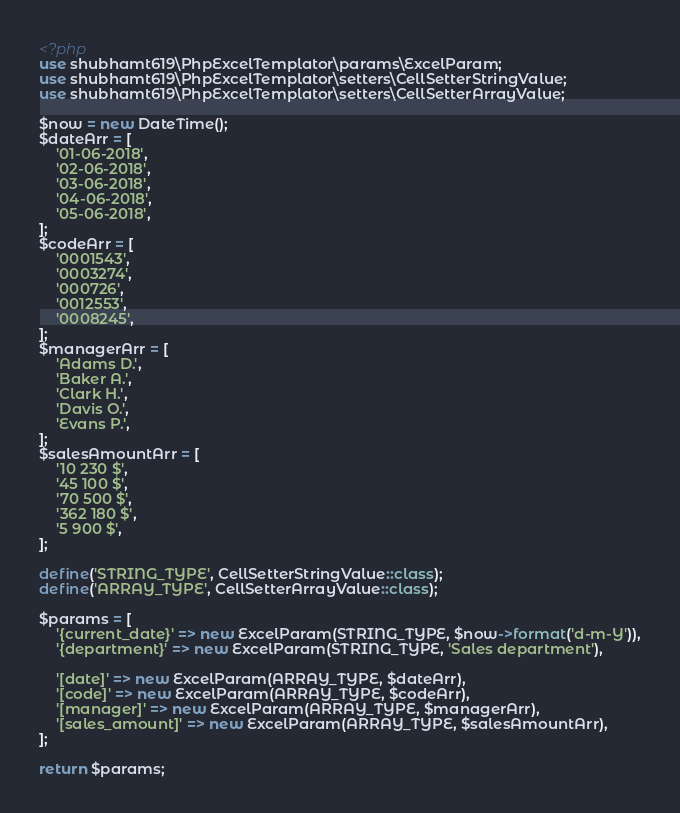<code> <loc_0><loc_0><loc_500><loc_500><_PHP_><?php
use shubhamt619\PhpExcelTemplator\params\ExcelParam;
use shubhamt619\PhpExcelTemplator\setters\CellSetterStringValue;
use shubhamt619\PhpExcelTemplator\setters\CellSetterArrayValue;

$now = new DateTime();
$dateArr = [
	'01-06-2018',
	'02-06-2018',
	'03-06-2018',
	'04-06-2018',
	'05-06-2018',
];
$codeArr = [
	'0001543',
	'0003274',
	'000726',
	'0012553',
	'0008245',
];
$managerArr = [
	'Adams D.',
	'Baker A.',
	'Clark H.',
	'Davis O.',
	'Evans P.',
];
$salesAmountArr = [
	'10 230 $',
	'45 100 $',
	'70 500 $',
	'362 180 $',
	'5 900 $',
];

define('STRING_TYPE', CellSetterStringValue::class);
define('ARRAY_TYPE', CellSetterArrayValue::class);

$params = [
	'{current_date}' => new ExcelParam(STRING_TYPE, $now->format('d-m-Y')),
	'{department}' => new ExcelParam(STRING_TYPE, 'Sales department'),

	'[date]' => new ExcelParam(ARRAY_TYPE, $dateArr),
	'[code]' => new ExcelParam(ARRAY_TYPE, $codeArr),
	'[manager]' => new ExcelParam(ARRAY_TYPE, $managerArr),
	'[sales_amount]' => new ExcelParam(ARRAY_TYPE, $salesAmountArr),
];

return $params;
</code> 